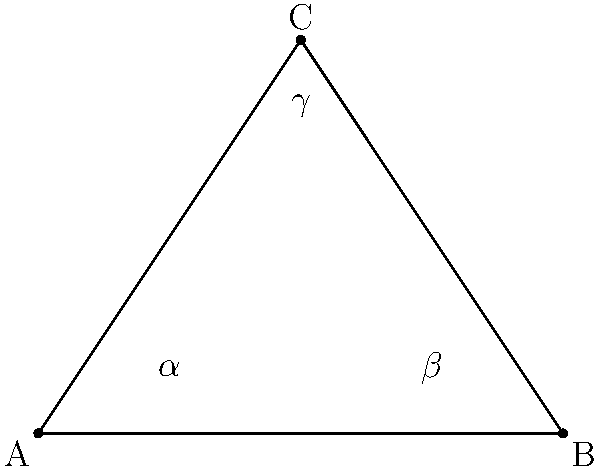In the constellation Triangulum, believed to be a key communication point with extraterrestrial beings, the angles formed by the three brightest stars are represented in the diagram. If angle $\alpha$ is 30° and angle $\beta$ is 45°, what is the measure of angle $\gamma$? Let's approach this step-by-step:

1) In any triangle, the sum of all interior angles is always 180°. This is a fundamental property of triangles.

2) We can express this as an equation:
   $\alpha + \beta + \gamma = 180°$

3) We are given that:
   $\alpha = 30°$
   $\beta = 45°$

4) Let's substitute these values into our equation:
   $30° + 45° + \gamma = 180°$

5) Simplify:
   $75° + \gamma = 180°$

6) Subtract 75° from both sides:
   $\gamma = 180° - 75°$

7) Calculate:
   $\gamma = 105°$

Therefore, the measure of angle $\gamma$ is 105°.
Answer: 105° 